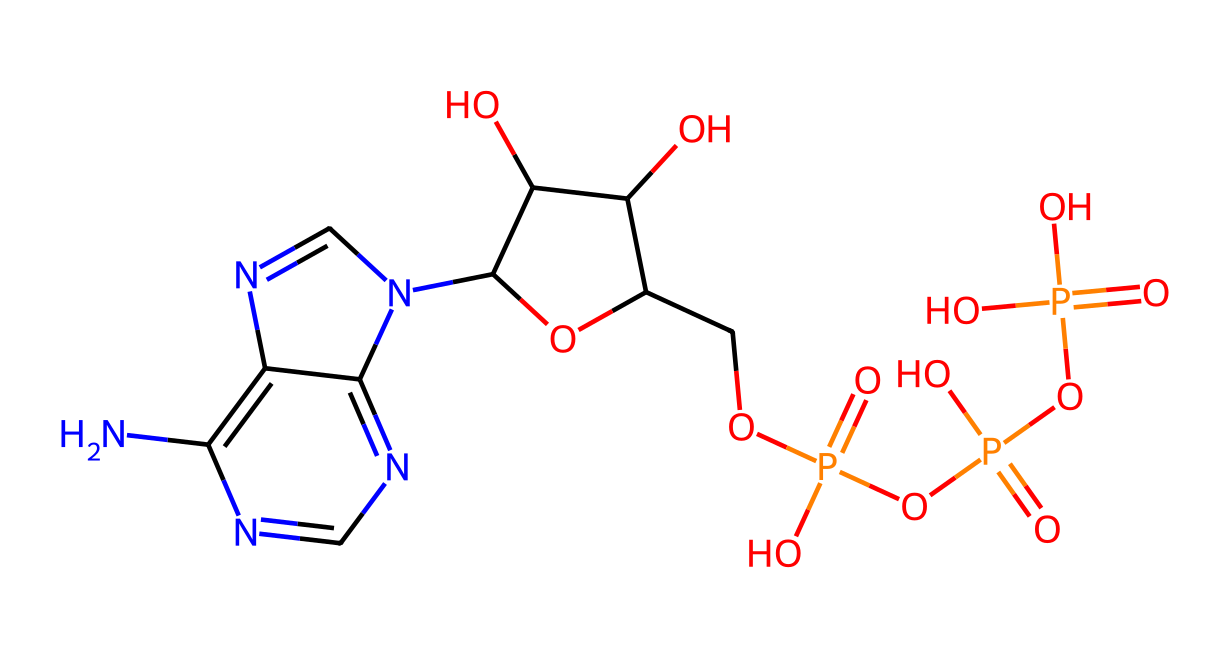What is the molecular formula of this compound? To determine the molecular formula, identify each atom represented in the SMILES notation and count their occurrences. The elements present are carbon (C), hydrogen (H), nitrogen (N), oxygen (O), and phosphorus (P). After counting, you find C is 10, H is 14, N is 5, O is 7, and P is 1, resulting in the molecular formula C10H14N5O7P.
Answer: C10H14N5O7P How many phosphate groups are present in the structure? In the structure annotated by the SMILES notation, phosphate groups are recognized by the 'P(=O)(O)' sequences. Counting these sequences reveals there are three phosphate groups in the adenosine triphosphate (ATP) structure.
Answer: 3 What type of compound is adenosine triphosphate? Adenosine triphosphate is identified as a nucleotide due to its composition of ribose, nitrogenous bases, and phosphate groups. Therefore, it is categorized specifically as a nucleotide.
Answer: nucleotide What is the role of this compound in athletes' bodies? ATP serves as the primary energy carrier in cells, crucial for fueling muscle contractions and other energy-demanding processes during athletic activity. This is what makes it vital for athletes.
Answer: energy carrier How many rings are present in the structure of ATP? Upon analyzing the chemical structure represented in the SMILES notation, there are two fused ring systems implied by the 'C1=NC(=C2...' section, indicating the presence of two significant rings.
Answer: 2 What is the significance of the nitrogen atoms in this compound? The nitrogen atoms play a crucial role by contributing to the structure of the nitrogenous base (adenine), which is essential for forming the nucleotide structure and participating in energy transfer processes.
Answer: nitrogenous base What type of bonds are mainly present between phosphate groups? In the structure of ATP, the predominant type of bond between the phosphate groups is phosphoanhydride bonds, known for linking the phosphate units and facilitating energy release.
Answer: phosphoanhydride bonds 